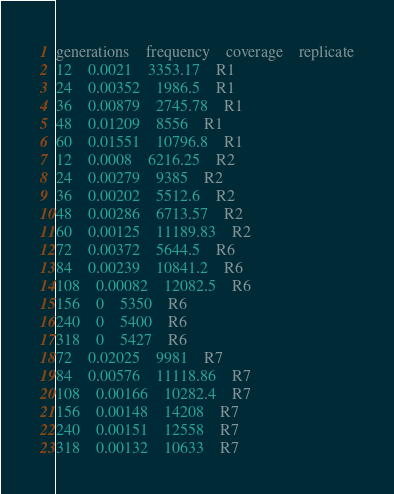<code> <loc_0><loc_0><loc_500><loc_500><_SQL_>generations	frequency	coverage	replicate
12	0.0021	3353.17	R1
24	0.00352	1986.5	R1
36	0.00879	2745.78	R1
48	0.01209	8556	R1
60	0.01551	10796.8	R1
12	0.0008	6216.25	R2
24	0.00279	9385	R2
36	0.00202	5512.6	R2
48	0.00286	6713.57	R2
60	0.00125	11189.83	R2
72	0.00372	5644.5	R6
84	0.00239	10841.2	R6
108	0.00082	12082.5	R6
156	0	5350	R6
240	0	5400	R6
318	0	5427	R6
72	0.02025	9981	R7
84	0.00576	11118.86	R7
108	0.00166	10282.4	R7
156	0.00148	14208	R7
240	0.00151	12558	R7
318	0.00132	10633	R7</code> 